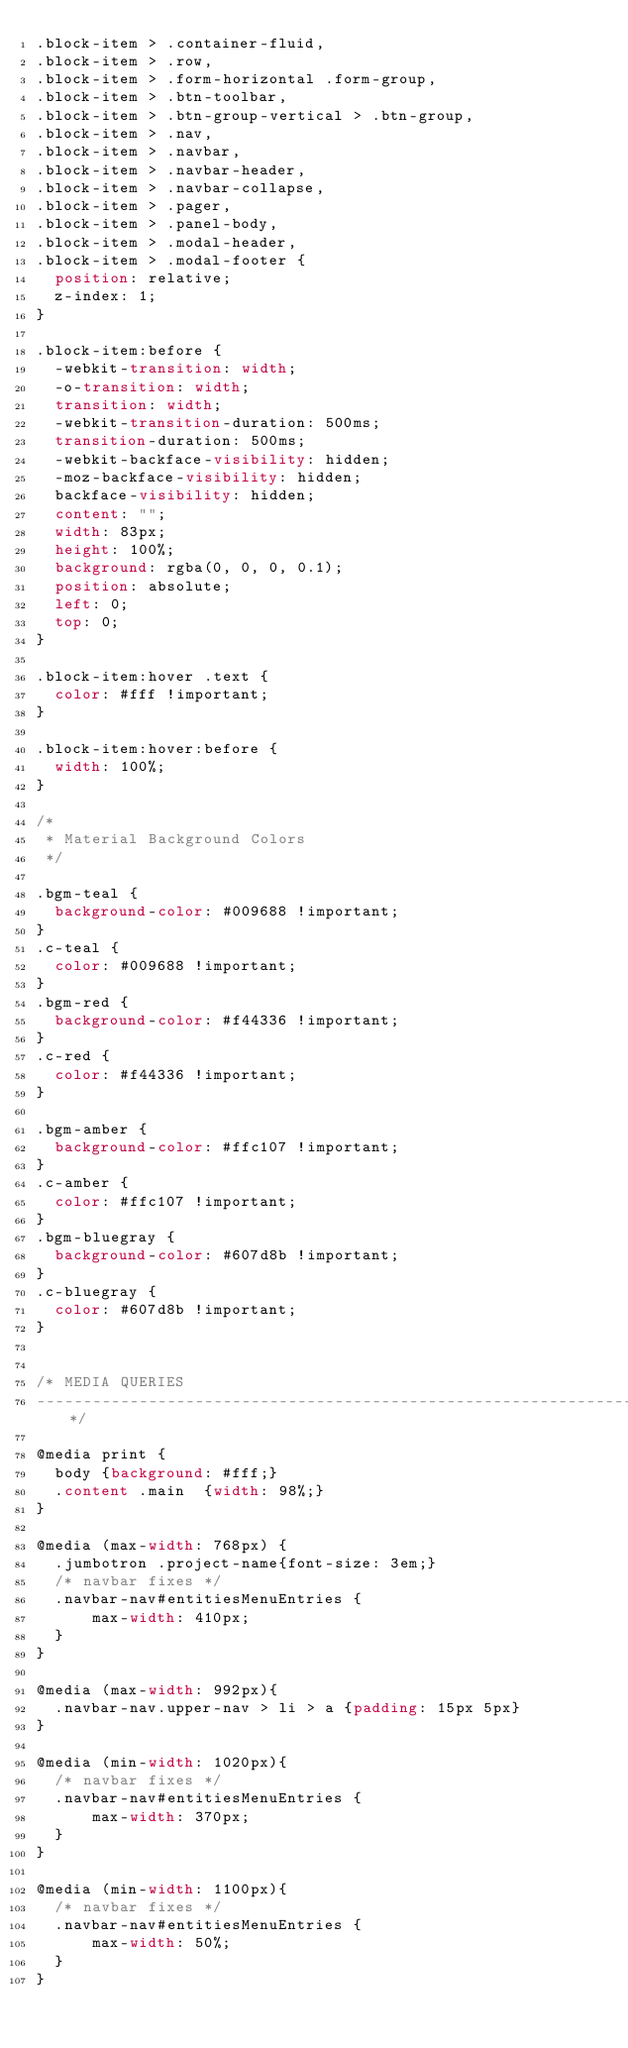Convert code to text. <code><loc_0><loc_0><loc_500><loc_500><_CSS_>.block-item > .container-fluid,
.block-item > .row,
.block-item > .form-horizontal .form-group,
.block-item > .btn-toolbar,
.block-item > .btn-group-vertical > .btn-group,
.block-item > .nav,
.block-item > .navbar,
.block-item > .navbar-header,
.block-item > .navbar-collapse,
.block-item > .pager,
.block-item > .panel-body,
.block-item > .modal-header,
.block-item > .modal-footer {
  position: relative;
  z-index: 1;
}

.block-item:before {
  -webkit-transition: width;
  -o-transition: width;
  transition: width;
  -webkit-transition-duration: 500ms;
  transition-duration: 500ms;
  -webkit-backface-visibility: hidden;
  -moz-backface-visibility: hidden;
  backface-visibility: hidden;
  content: "";
  width: 83px;
  height: 100%;
  background: rgba(0, 0, 0, 0.1);
  position: absolute;
  left: 0;
  top: 0;
}

.block-item:hover .text {
  color: #fff !important;
}

.block-item:hover:before {
  width: 100%;
}

/*
 * Material Background Colors
 */

.bgm-teal {
  background-color: #009688 !important;
}
.c-teal {
  color: #009688 !important;
}
.bgm-red {
  background-color: #f44336 !important;
}
.c-red {
  color: #f44336 !important;
}

.bgm-amber {
  background-color: #ffc107 !important;
}
.c-amber {
  color: #ffc107 !important;
}
.bgm-bluegray {
  background-color: #607d8b !important;
}
.c-bluegray {
  color: #607d8b !important;
}


/* MEDIA QUERIES
----------------------------------------------------------------------------------------------------*/

@media print {
  body {background: #fff;}
  .content .main  {width: 98%;}
}

@media (max-width: 768px) {
  .jumbotron .project-name{font-size: 3em;}
  /* navbar fixes */
  .navbar-nav#entitiesMenuEntries {
      max-width: 410px;
  }
}

@media (max-width: 992px){
  .navbar-nav.upper-nav > li > a {padding: 15px 5px}
}

@media (min-width: 1020px){
  /* navbar fixes */
  .navbar-nav#entitiesMenuEntries {
      max-width: 370px;
  }
}

@media (min-width: 1100px){
  /* navbar fixes */
  .navbar-nav#entitiesMenuEntries {
      max-width: 50%;
  }
}
</code> 